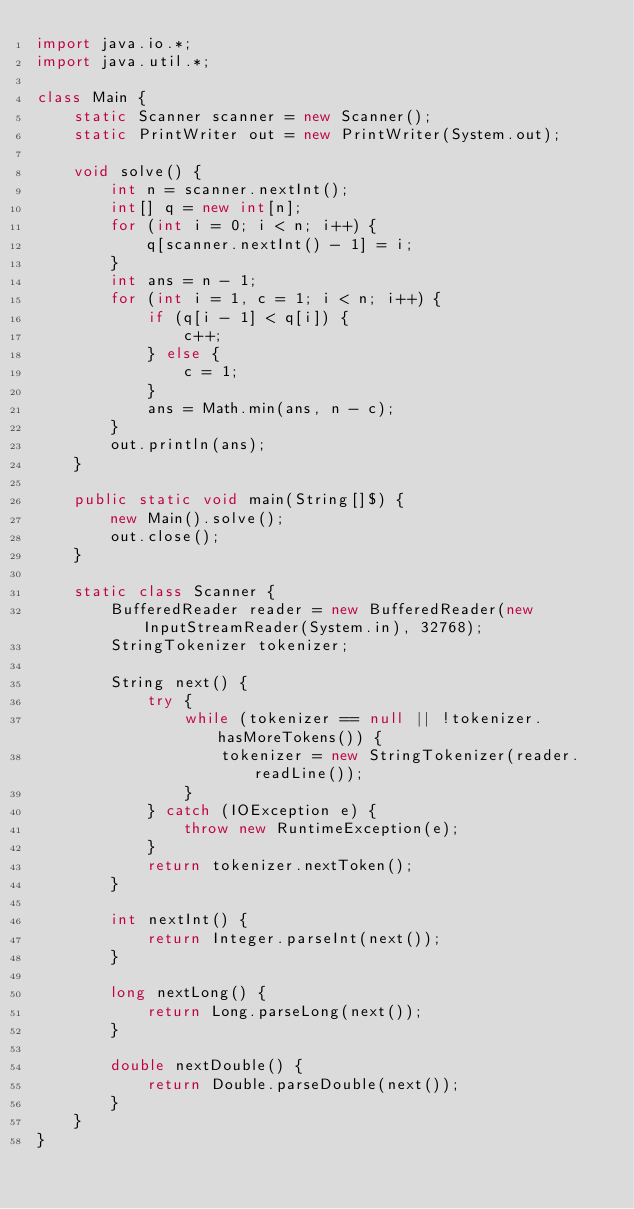<code> <loc_0><loc_0><loc_500><loc_500><_Java_>import java.io.*;
import java.util.*;

class Main {
    static Scanner scanner = new Scanner();
    static PrintWriter out = new PrintWriter(System.out);

    void solve() {
        int n = scanner.nextInt();
        int[] q = new int[n];
        for (int i = 0; i < n; i++) {
            q[scanner.nextInt() - 1] = i;
        }
        int ans = n - 1;
        for (int i = 1, c = 1; i < n; i++) {
            if (q[i - 1] < q[i]) {
                c++;
            } else {
                c = 1;
            }
            ans = Math.min(ans, n - c);
        }
        out.println(ans);
    }

    public static void main(String[]$) {
        new Main().solve();
        out.close();
    }

    static class Scanner {
        BufferedReader reader = new BufferedReader(new InputStreamReader(System.in), 32768);
        StringTokenizer tokenizer;

        String next() {
            try {
                while (tokenizer == null || !tokenizer.hasMoreTokens()) {
                    tokenizer = new StringTokenizer(reader.readLine());
                }
            } catch (IOException e) {
                throw new RuntimeException(e);
            }
            return tokenizer.nextToken();
        }

        int nextInt() {
            return Integer.parseInt(next());
        }

        long nextLong() {
            return Long.parseLong(next());
        }

        double nextDouble() {
            return Double.parseDouble(next());
        }
    }
}</code> 